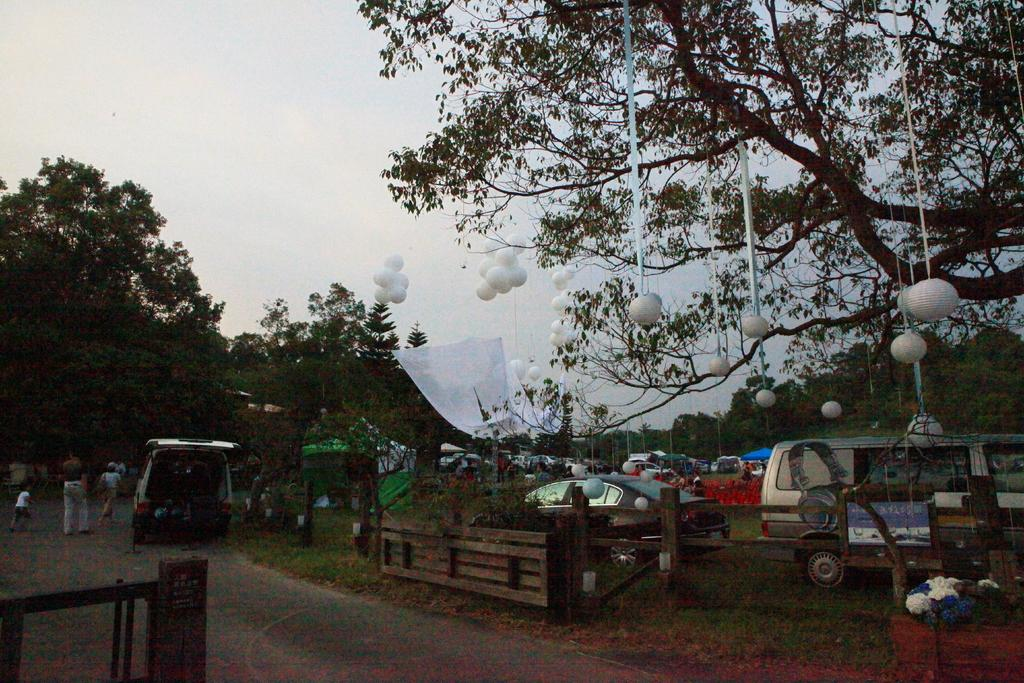What types of objects can be seen in the image? There are vehicles, trees, decorative lights, balloons, plants, and flowers visible in the image. What is the condition of the sky in the image? The sky is cloudy in the image. What additional objects can be seen in the image? There are boards present in the image. What type of sound can be heard coming from the story in the image? There is no story present in the image, and therefore no sound can be heard from it. 